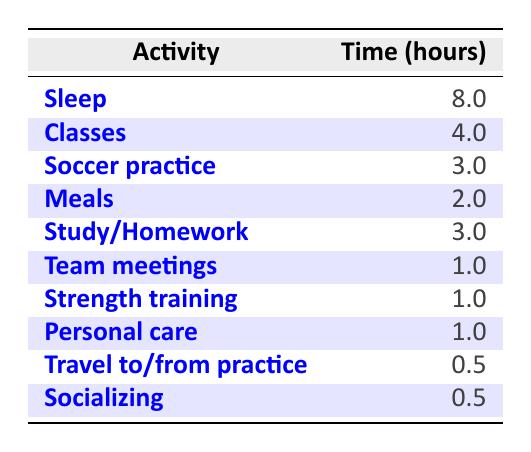What is the total time spent on soccer-related activities? The table lists soccer practice (3 hours) and strength training (1 hour) as the soccer-related activities. Adding these two values gives 3 + 1 = 4 hours.
Answer: 4 hours How many hours are allocated for classes and studying combined? The table states that classes take 4 hours and study/homework takes another 3 hours. Adding these together results in 4 + 3 = 7 hours.
Answer: 7 hours Is the time for meals greater than the time for team meetings? Meals take 2 hours and team meetings take 1 hour according to the table. Since 2 is greater than 1, the statement is true.
Answer: Yes What percentage of the total day (24 hours) is dedicated to sleep? The table indicates that sleep takes 8 hours. To find the percentage, divide 8 by 24 and multiply by 100: (8/24) * 100 = approximately 33.33%.
Answer: Approximately 33.33% What is the average time spent on personal care and socializing? Personal care takes 1 hour and socializing also takes 0.5 hours. To find the average, we first sum these times: 1 + 0.5 = 1.5 hours. Since there are 2 activities, we divide 1.5 by 2, resulting in 1.5/2 = 0.75 hours.
Answer: 0.75 hours How many hours are spent on travel compared to other activities? According to the table, travel to/from practice takes 0.5 hours. If we compare this to the total of 18 hours from the other activities (adding 8 hours sleep, 4 hours classes, 3 hours practice, 2 hours meals, 3 hours study, etc.), travel is less than 1 hour while most other activities are greater than or equal to 1 hour.
Answer: Less than most activities Which activity takes the least amount of time? Looking at the table, both travel to/from practice and socializing take 0.5 hours, which is the least amount of time compared to other activities listed.
Answer: Travel to/from practice and socializing What is the total time spent on classes, homework, and team meetings together? The time for classes is 4 hours, homework is 3 hours, and team meetings are 1 hour. Adding these values gives 4 + 3 + 1 = 8 hours.
Answer: 8 hours Is the total time spent on meals and personal care more than the time spent on strength training? Meals take 2 hours and personal care takes 1 hour, totaling 3 hours. Strength training takes 1 hour. Since 3 hours is greater than 1 hour, the statement is correct.
Answer: Yes 